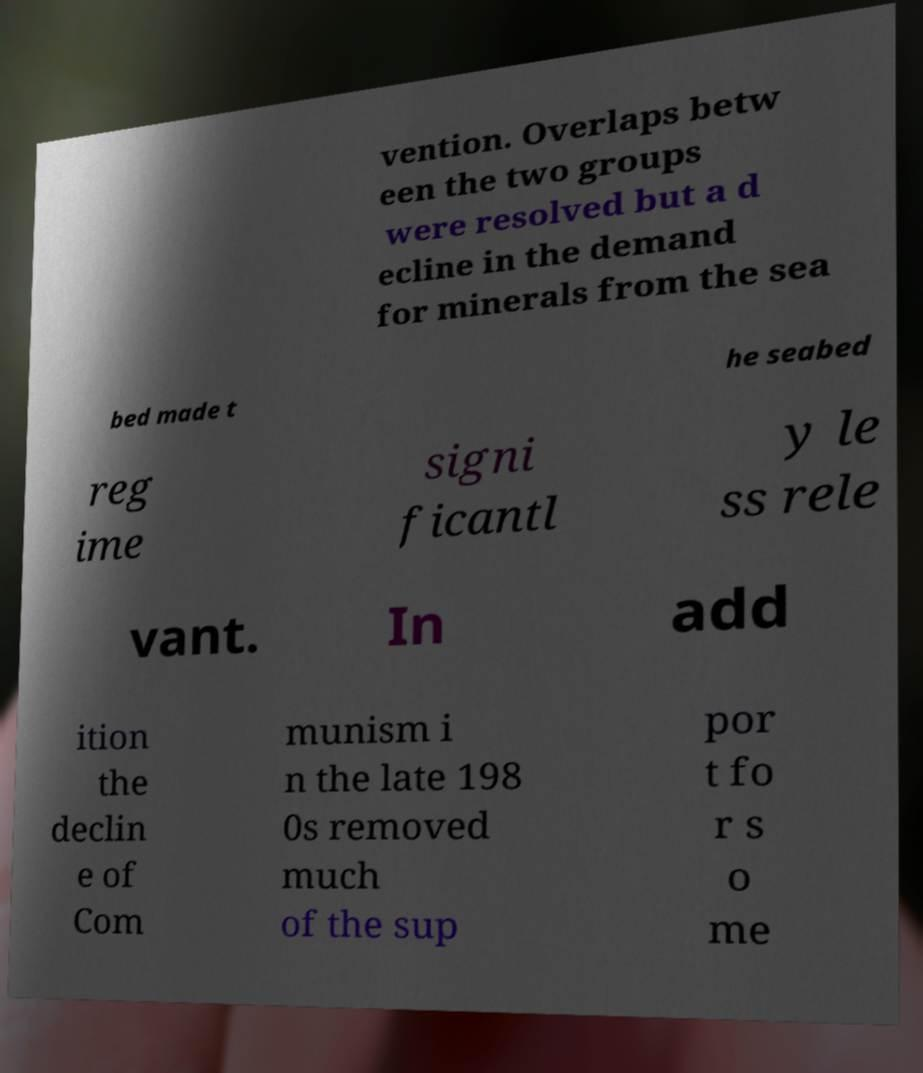I need the written content from this picture converted into text. Can you do that? vention. Overlaps betw een the two groups were resolved but a d ecline in the demand for minerals from the sea bed made t he seabed reg ime signi ficantl y le ss rele vant. In add ition the declin e of Com munism i n the late 198 0s removed much of the sup por t fo r s o me 